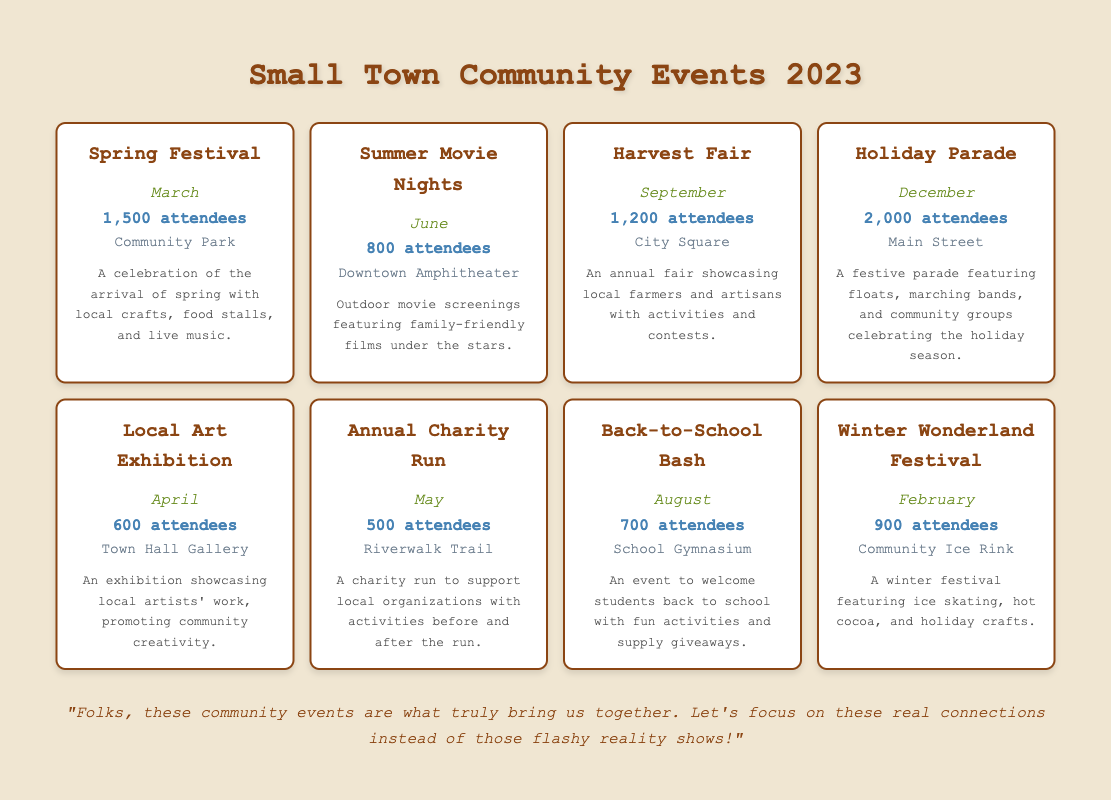What event had the highest attendance in 2023? By looking at the attendance numbers in the table, the event with the highest attendance is the Holiday Parade, which had 2,000 attendees.
Answer: 2,000 How many attendees were there for the Winter Wonderland Festival? The table specifies that the Winter Wonderland Festival had 900 attendees.
Answer: 900 Which month had the lowest attendance? Analyzing the attendance numbers, the Annual Charity Run in May had the lowest attendance with 500 attendees.
Answer: May What is the total attendance for the events occurring in the summer months (June, July, and August)? The table shows Summer Movie Nights in June with 800 attendees, and Back-to-School Bash in August with 700 attendees. For July, there are no events listed. The total is 800 + 700 = 1500.
Answer: 1500 Is the attendance for the Local Art Exhibition greater than the Annual Charity Run? The Local Art Exhibition had 600 attendees and the Annual Charity Run had 500 attendees, so yes, the attendance for the Local Art Exhibition is greater.
Answer: Yes Which event occurs in April and what is its attendance? The event in April is the Local Art Exhibition, and it had 600 attendees according to the table.
Answer: Local Art Exhibition, 600 What is the average attendance of all events in 2023? To find the average, we sum the attendance numbers: 1500 + 800 + 1200 + 2000 + 600 + 500 + 700 + 900 = 6200. There are 8 events, so we divide 6200 by 8 to get the average: 6200 / 8 = 775.
Answer: 775 Did the Harvest Fair have more attendees than the Spring Festival? Comparing the figures, the Harvest Fair had 1,200 attendees, and the Spring Festival had 1,500 attendees; therefore, the Harvest Fair did not have more attendees.
Answer: No What percentage of attendees at the Holiday Parade represents the total attendance of all events? The Holiday Parade had 2,000 attendees out of a total of 6,200. To find the percentage, divide 2,000 by 6,200 and multiply by 100, which gives approximately 32.26%.
Answer: 32.26% 